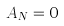<formula> <loc_0><loc_0><loc_500><loc_500>A _ { N } = 0</formula> 